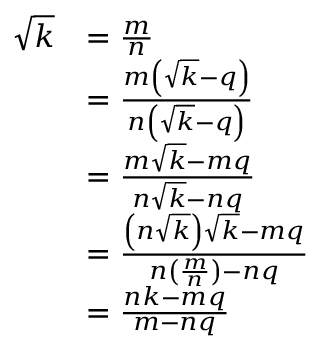Convert formula to latex. <formula><loc_0><loc_0><loc_500><loc_500>{ \begin{array} { r l } { { \sqrt { k } } } & { = { \frac { m } { n } } } \\ & { = { \frac { m \left ( { \sqrt { k } } - q \right ) } { n \left ( { \sqrt { k } } - q \right ) } } } \\ & { = { \frac { m { \sqrt { k } } - m q } { n { \sqrt { k } } - n q } } } \\ & { = { \frac { \left ( n { \sqrt { k } } \right ) { \sqrt { k } } - m q } { n \left ( { \frac { m } { n } } \right ) - n q } } } \\ & { = { \frac { n k - m q } { m - n q } } } \end{array} }</formula> 